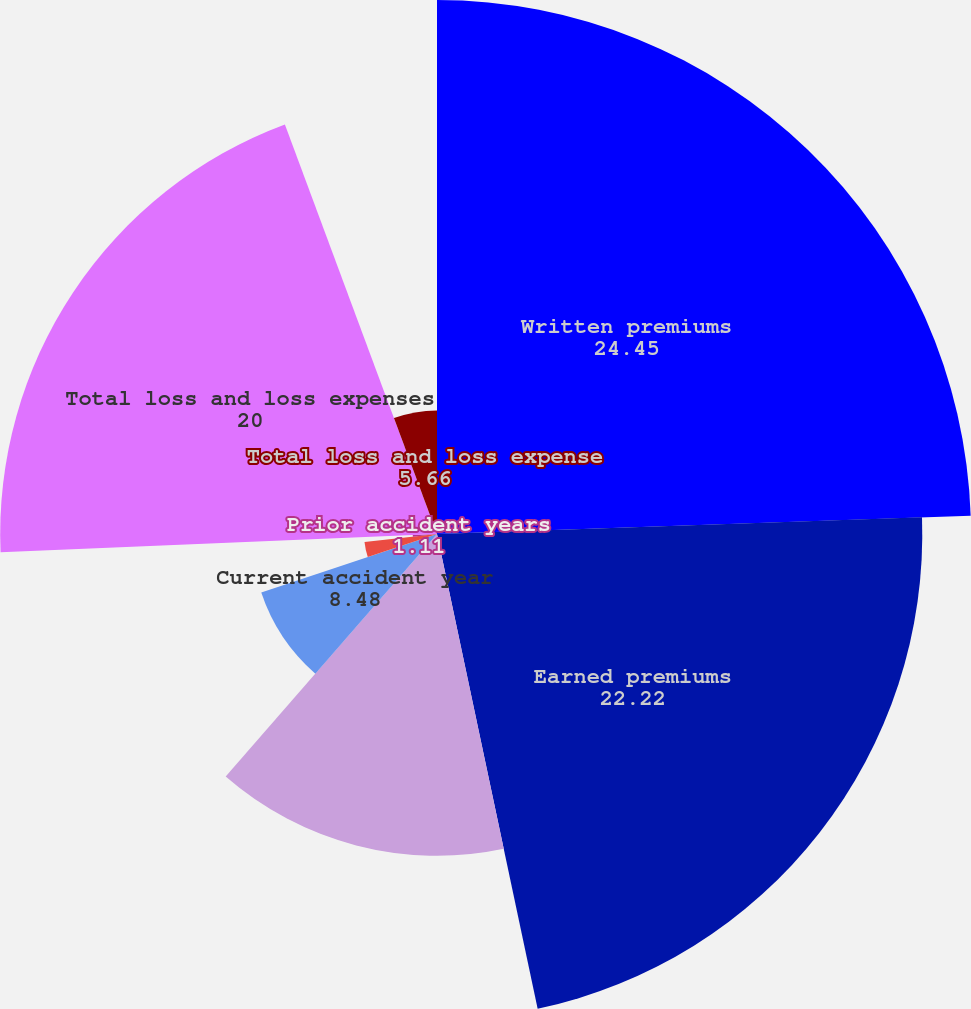Convert chart to OTSL. <chart><loc_0><loc_0><loc_500><loc_500><pie_chart><fcel>Written premiums<fcel>Earned premiums<fcel>Current accident year before<fcel>Current accident year<fcel>Prior accident years before<fcel>Prior accident years<fcel>Total loss and loss expenses<fcel>Total loss and loss expense<nl><fcel>24.45%<fcel>22.22%<fcel>14.73%<fcel>8.48%<fcel>3.34%<fcel>1.11%<fcel>20.0%<fcel>5.66%<nl></chart> 